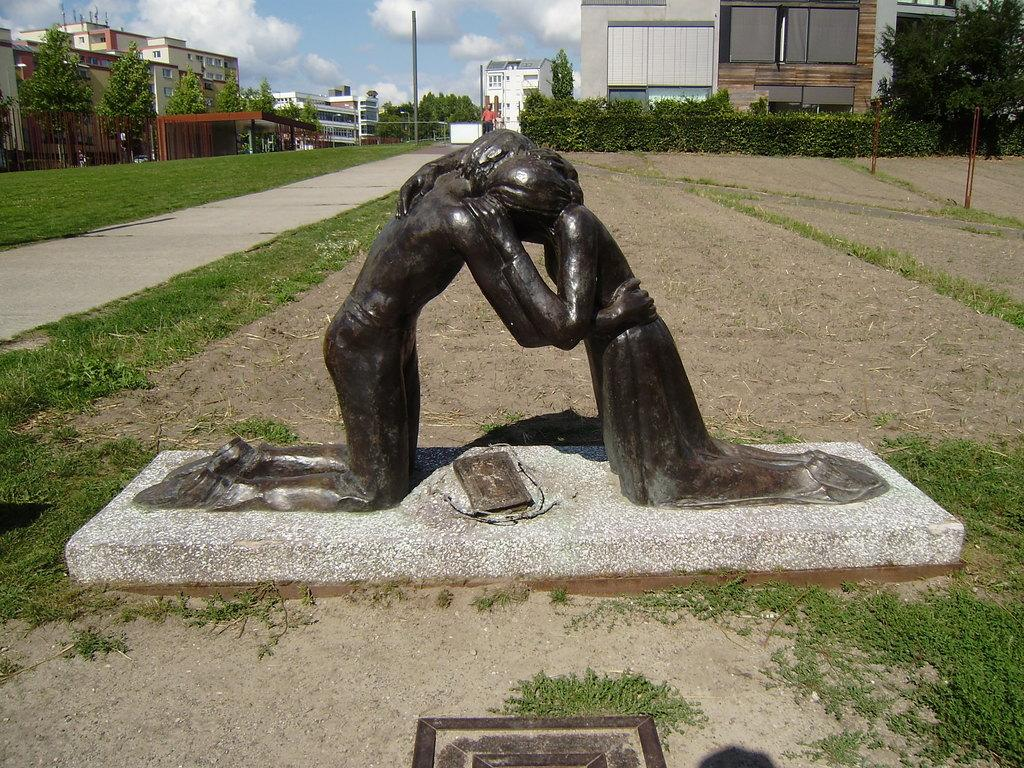What can be seen at the front of the image? There are statues in the front of the image. What type of vegetation is visible in the background of the image? There is grass, trees, and plants in the background of the image. What other objects can be seen in the background of the image? There is a pole and buildings in the background of the image. What is visible at the top of the image? The sky is visible at the top of the image. What can be observed in the sky? There are clouds in the sky. Can you see a guitar being played by one of the statues in the image? There is no guitar present in the image, and the statues are not depicted as playing any instruments. What type of bag is hanging from the trees in the background of the image? There are no bags hanging from the trees in the background of the image. 